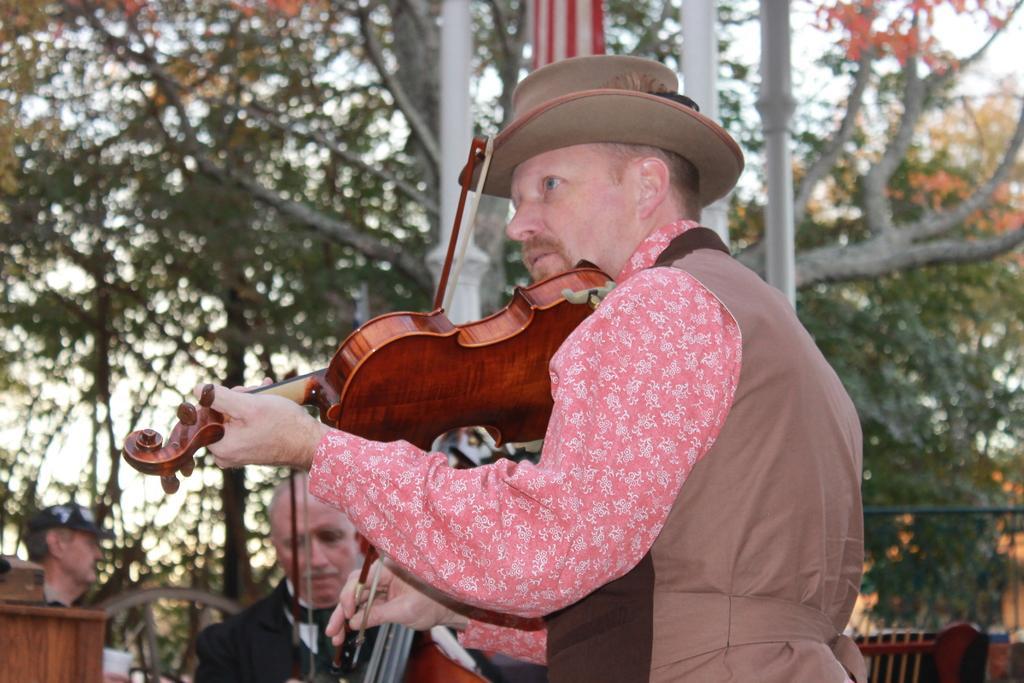Describe this image in one or two sentences. In this image I can see number of people where he is holding a musical instrument in his hand. In the background I can see few trees. 